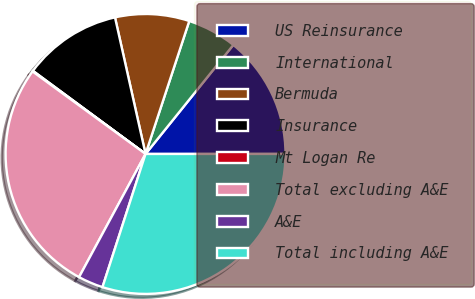<chart> <loc_0><loc_0><loc_500><loc_500><pie_chart><fcel>US Reinsurance<fcel>International<fcel>Bermuda<fcel>Insurance<fcel>Mt Logan Re<fcel>Total excluding A&E<fcel>A&E<fcel>Total including A&E<nl><fcel>14.21%<fcel>5.73%<fcel>8.56%<fcel>11.38%<fcel>0.08%<fcel>27.16%<fcel>2.9%<fcel>29.98%<nl></chart> 